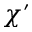Convert formula to latex. <formula><loc_0><loc_0><loc_500><loc_500>\chi ^ { \prime }</formula> 